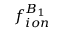<formula> <loc_0><loc_0><loc_500><loc_500>f _ { i o n } ^ { B _ { 1 } }</formula> 